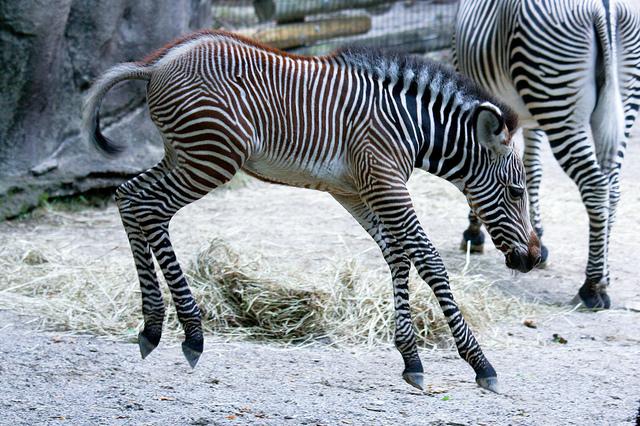Is the baby zebra standing still?
Give a very brief answer. No. Are the zebras in thick grass?
Give a very brief answer. No. Is this a zebra family?
Short answer required. Yes. 